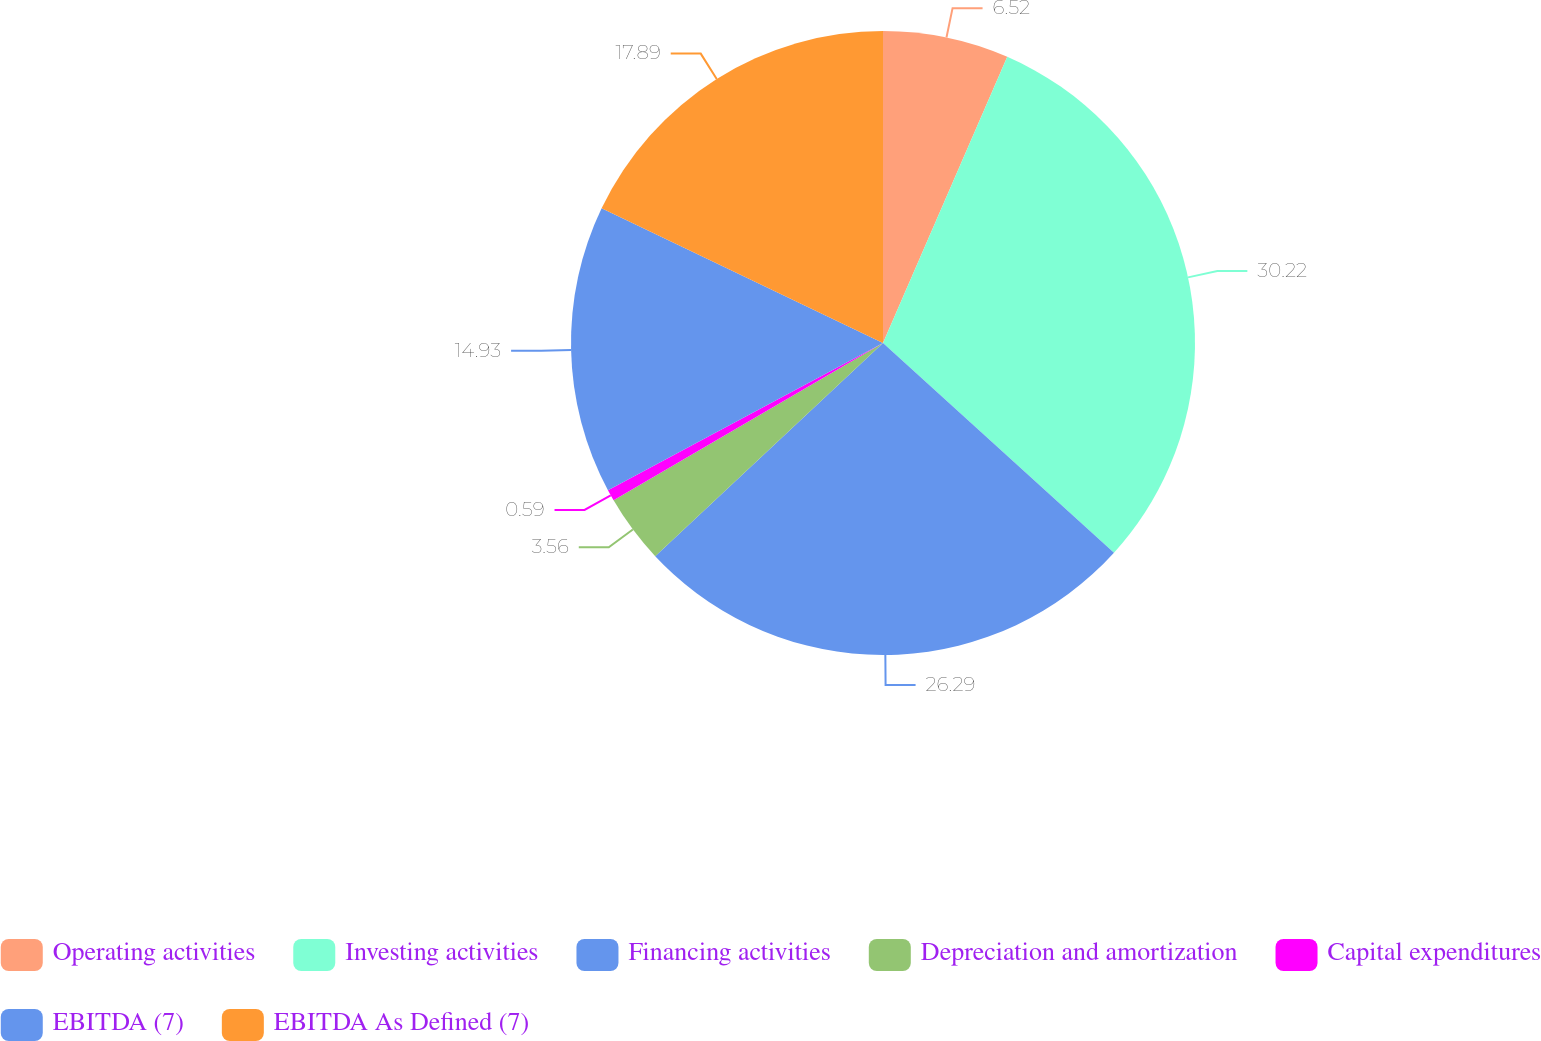Convert chart. <chart><loc_0><loc_0><loc_500><loc_500><pie_chart><fcel>Operating activities<fcel>Investing activities<fcel>Financing activities<fcel>Depreciation and amortization<fcel>Capital expenditures<fcel>EBITDA (7)<fcel>EBITDA As Defined (7)<nl><fcel>6.52%<fcel>30.21%<fcel>26.29%<fcel>3.56%<fcel>0.59%<fcel>14.93%<fcel>17.89%<nl></chart> 